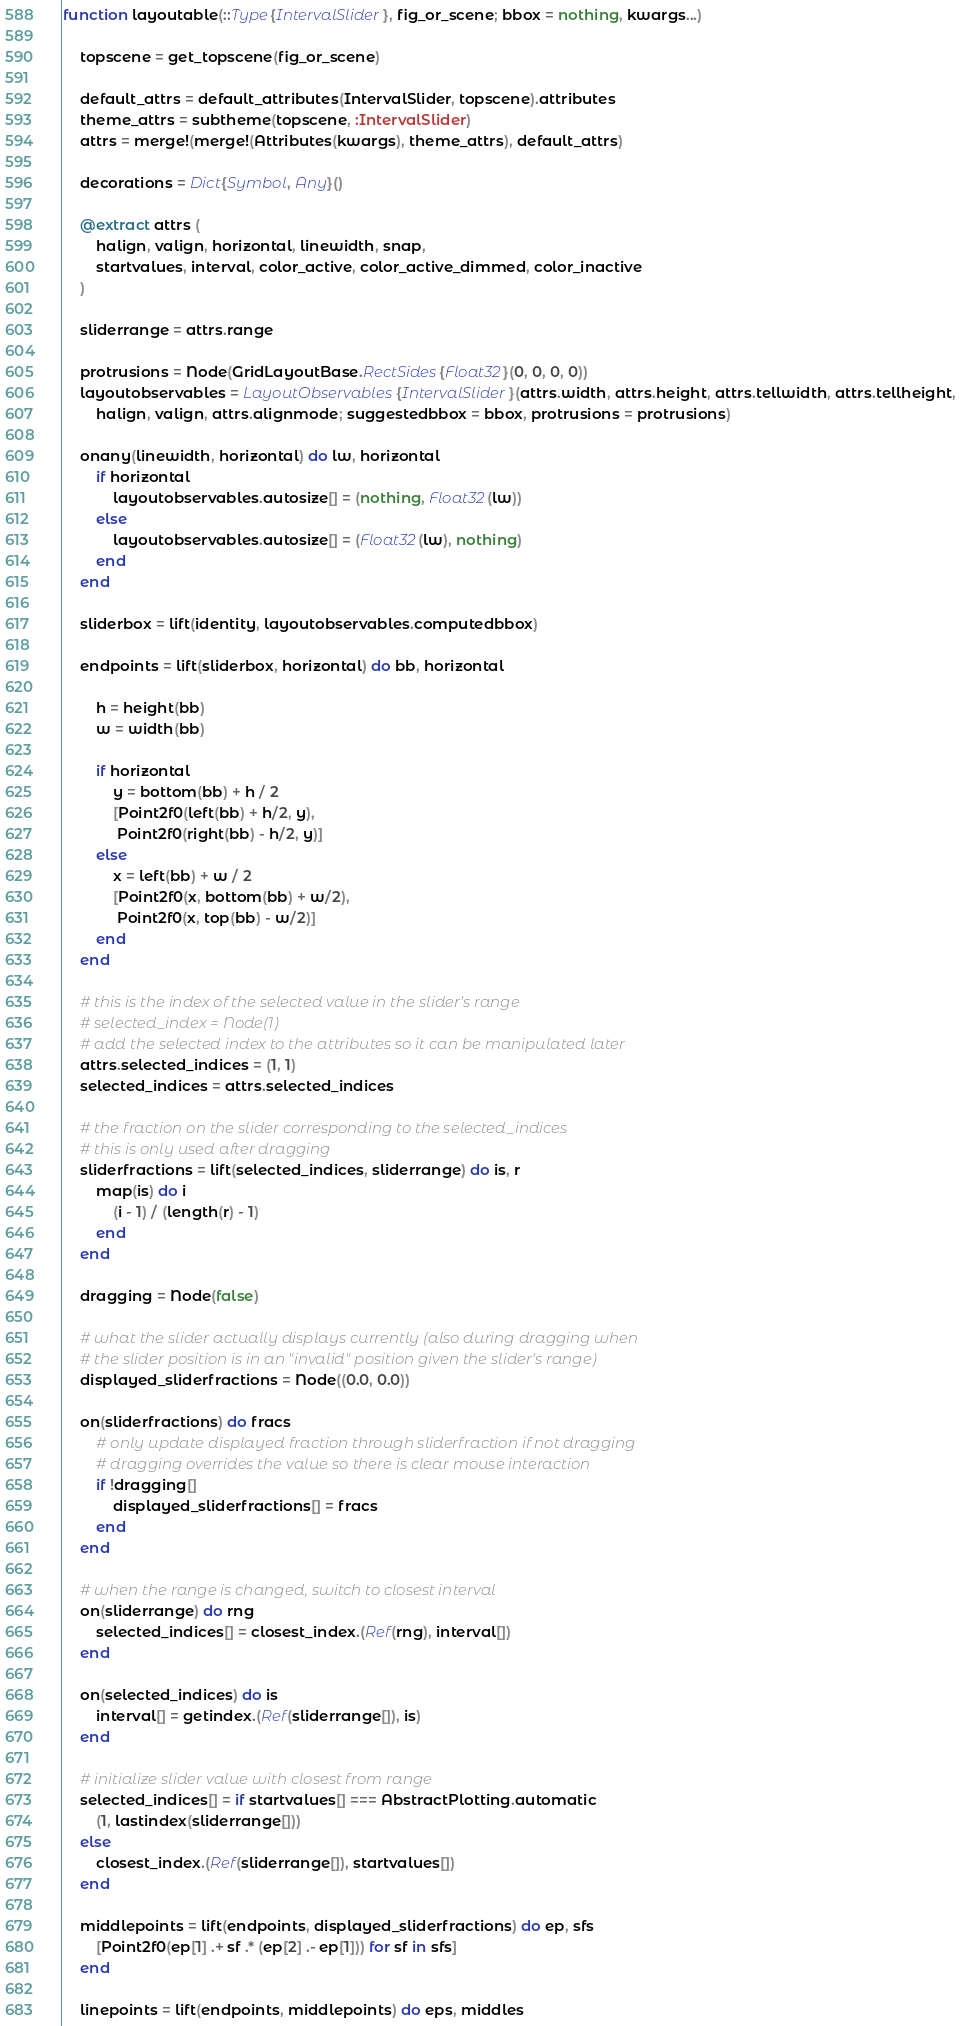Convert code to text. <code><loc_0><loc_0><loc_500><loc_500><_Julia_>function layoutable(::Type{IntervalSlider}, fig_or_scene; bbox = nothing, kwargs...)

    topscene = get_topscene(fig_or_scene)

    default_attrs = default_attributes(IntervalSlider, topscene).attributes
    theme_attrs = subtheme(topscene, :IntervalSlider)
    attrs = merge!(merge!(Attributes(kwargs), theme_attrs), default_attrs)

    decorations = Dict{Symbol, Any}()

    @extract attrs (
        halign, valign, horizontal, linewidth, snap,
        startvalues, interval, color_active, color_active_dimmed, color_inactive
    )

    sliderrange = attrs.range

    protrusions = Node(GridLayoutBase.RectSides{Float32}(0, 0, 0, 0))
    layoutobservables = LayoutObservables{IntervalSlider}(attrs.width, attrs.height, attrs.tellwidth, attrs.tellheight,
        halign, valign, attrs.alignmode; suggestedbbox = bbox, protrusions = protrusions)

    onany(linewidth, horizontal) do lw, horizontal
        if horizontal
            layoutobservables.autosize[] = (nothing, Float32(lw))
        else
            layoutobservables.autosize[] = (Float32(lw), nothing)
        end
    end

    sliderbox = lift(identity, layoutobservables.computedbbox)

    endpoints = lift(sliderbox, horizontal) do bb, horizontal

        h = height(bb)
        w = width(bb)

        if horizontal
            y = bottom(bb) + h / 2
            [Point2f0(left(bb) + h/2, y),
             Point2f0(right(bb) - h/2, y)]
        else
            x = left(bb) + w / 2
            [Point2f0(x, bottom(bb) + w/2),
             Point2f0(x, top(bb) - w/2)]
        end
    end

    # this is the index of the selected value in the slider's range
    # selected_index = Node(1)
    # add the selected index to the attributes so it can be manipulated later
    attrs.selected_indices = (1, 1)
    selected_indices = attrs.selected_indices

    # the fraction on the slider corresponding to the selected_indices
    # this is only used after dragging
    sliderfractions = lift(selected_indices, sliderrange) do is, r
        map(is) do i
            (i - 1) / (length(r) - 1)
        end
    end

    dragging = Node(false)

    # what the slider actually displays currently (also during dragging when
    # the slider position is in an "invalid" position given the slider's range)
    displayed_sliderfractions = Node((0.0, 0.0))

    on(sliderfractions) do fracs
        # only update displayed fraction through sliderfraction if not dragging
        # dragging overrides the value so there is clear mouse interaction
        if !dragging[]
            displayed_sliderfractions[] = fracs
        end
    end

    # when the range is changed, switch to closest interval
    on(sliderrange) do rng
        selected_indices[] = closest_index.(Ref(rng), interval[])
    end

    on(selected_indices) do is
        interval[] = getindex.(Ref(sliderrange[]), is)
    end

    # initialize slider value with closest from range
    selected_indices[] = if startvalues[] === AbstractPlotting.automatic
        (1, lastindex(sliderrange[]))
    else
        closest_index.(Ref(sliderrange[]), startvalues[])
    end

    middlepoints = lift(endpoints, displayed_sliderfractions) do ep, sfs
        [Point2f0(ep[1] .+ sf .* (ep[2] .- ep[1])) for sf in sfs]
    end

    linepoints = lift(endpoints, middlepoints) do eps, middles</code> 